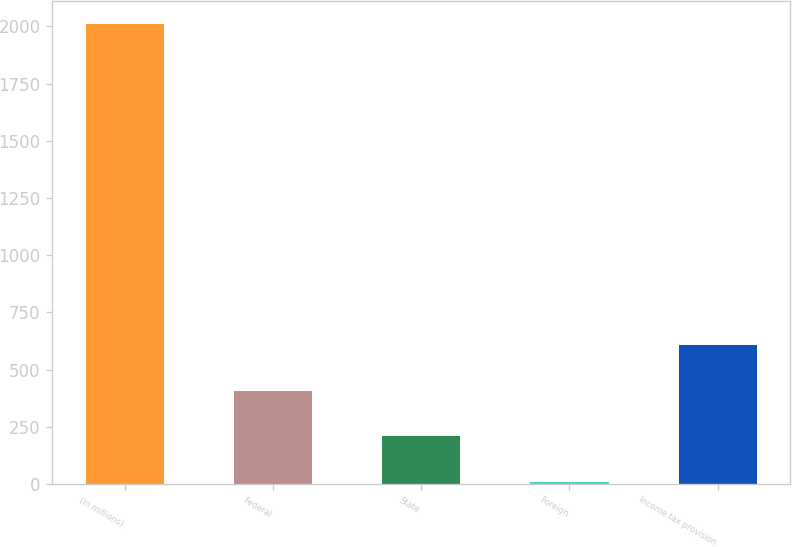Convert chart to OTSL. <chart><loc_0><loc_0><loc_500><loc_500><bar_chart><fcel>(In millions)<fcel>Federal<fcel>State<fcel>Foreign<fcel>Income tax provision<nl><fcel>2010<fcel>408.4<fcel>208.2<fcel>8<fcel>608.6<nl></chart> 